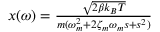<formula> <loc_0><loc_0><loc_500><loc_500>\begin{array} { r } { x ( \omega ) = \frac { \sqrt { 2 \beta k _ { B } T } } { m ( \omega _ { m } ^ { 2 } + 2 \zeta _ { m } \omega _ { m } s + s ^ { 2 } ) } } \end{array}</formula> 